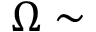<formula> <loc_0><loc_0><loc_500><loc_500>\Omega \sim</formula> 